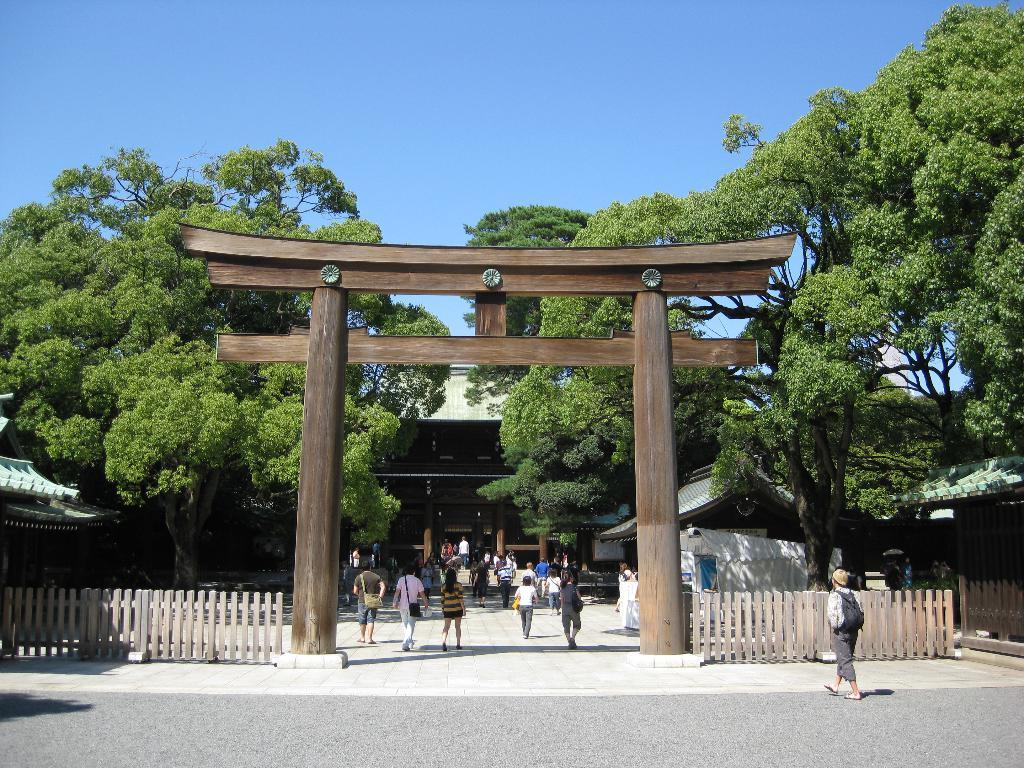What is the person in the image doing? There is a person walking on the road in the image. What can be seen in the background of the image? In the background, there is architecture, fencing, persons on the road, trees, and buildings. What is the color of the sky in the image? The sky is blue in the image. What type of necklace is the person wearing in the image? There is no necklace visible on the person in the image. What channel is the person watching on the road in the image? There is no television or channel present in the image; it is a person walking on the road. 